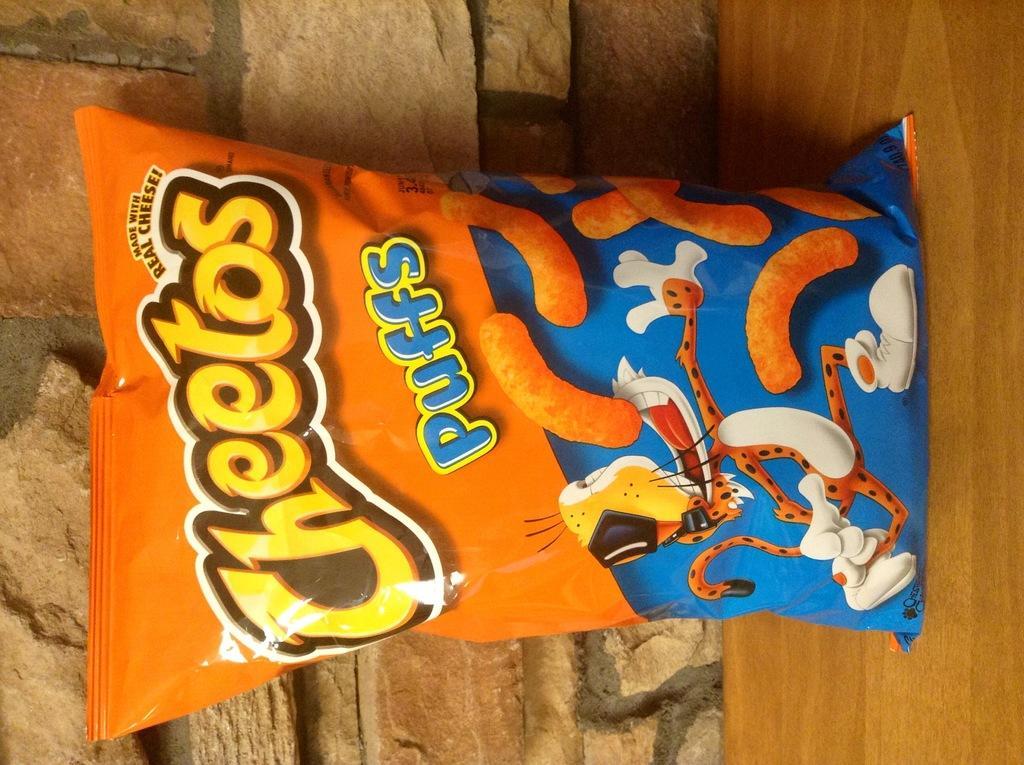Could you give a brief overview of what you see in this image? In this image we can see a packet on a wooden surface. On the packet there is something written. In the back there is a wall. 